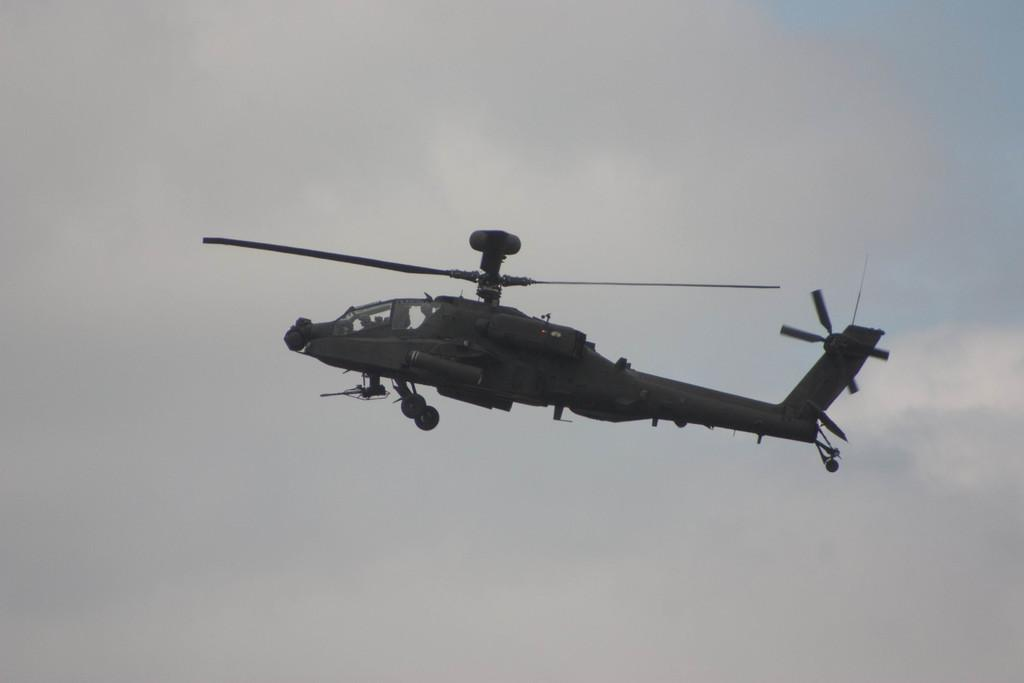What is the main subject of the image? The main subject of the image is a helicopter. Can you describe the position of the helicopter in the image? The helicopter is in the air in the image. What else can be seen in the sky in the image? There are clouds visible in the image. How does the helicopter increase the selection of books in the image? The image does not show any books or any indication of a selection being increased. The helicopter is simply in the air, and there are clouds visible in the sky. 